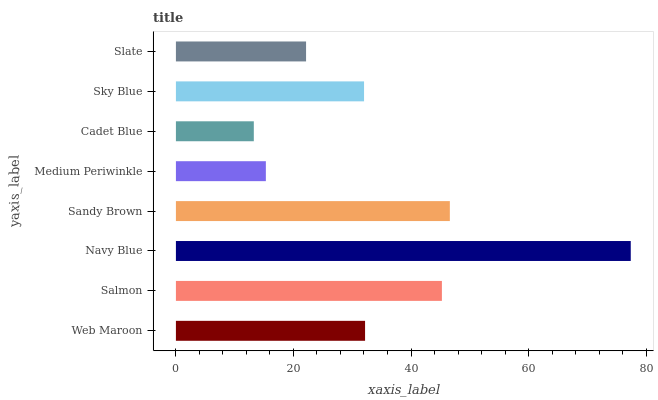Is Cadet Blue the minimum?
Answer yes or no. Yes. Is Navy Blue the maximum?
Answer yes or no. Yes. Is Salmon the minimum?
Answer yes or no. No. Is Salmon the maximum?
Answer yes or no. No. Is Salmon greater than Web Maroon?
Answer yes or no. Yes. Is Web Maroon less than Salmon?
Answer yes or no. Yes. Is Web Maroon greater than Salmon?
Answer yes or no. No. Is Salmon less than Web Maroon?
Answer yes or no. No. Is Web Maroon the high median?
Answer yes or no. Yes. Is Sky Blue the low median?
Answer yes or no. Yes. Is Sky Blue the high median?
Answer yes or no. No. Is Cadet Blue the low median?
Answer yes or no. No. 